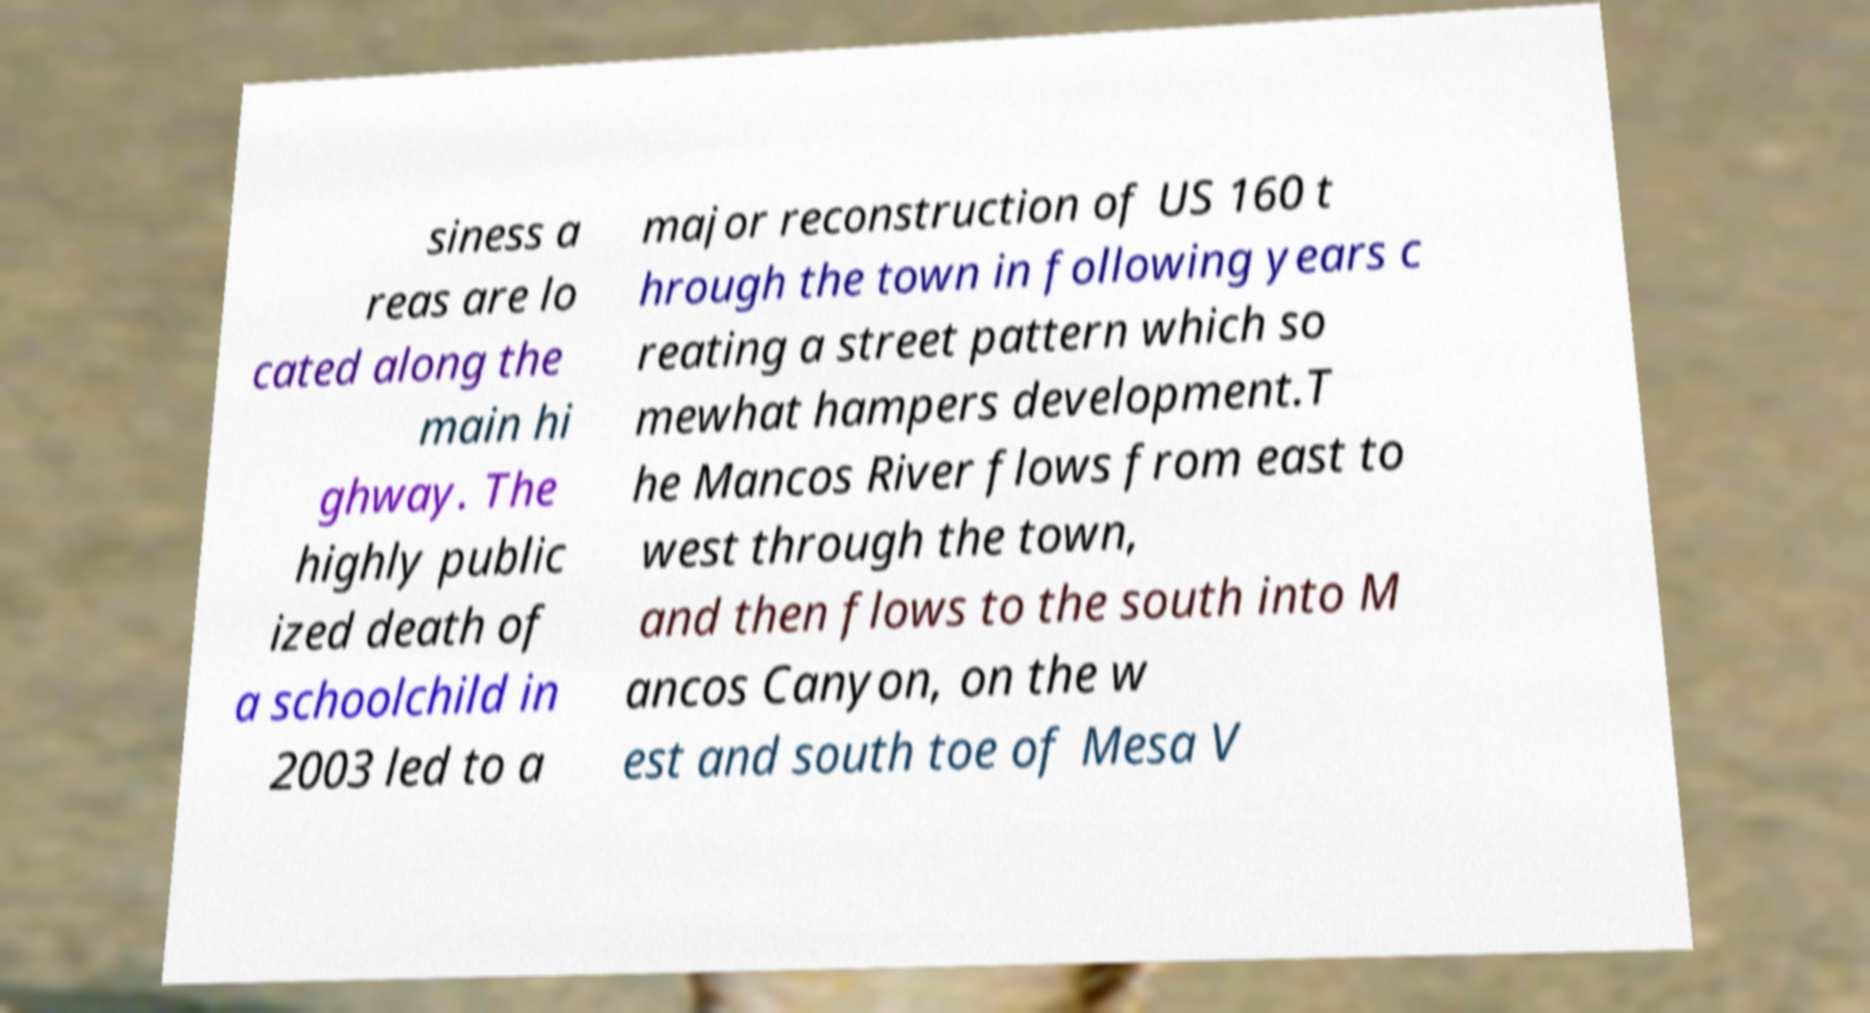Can you read and provide the text displayed in the image?This photo seems to have some interesting text. Can you extract and type it out for me? siness a reas are lo cated along the main hi ghway. The highly public ized death of a schoolchild in 2003 led to a major reconstruction of US 160 t hrough the town in following years c reating a street pattern which so mewhat hampers development.T he Mancos River flows from east to west through the town, and then flows to the south into M ancos Canyon, on the w est and south toe of Mesa V 